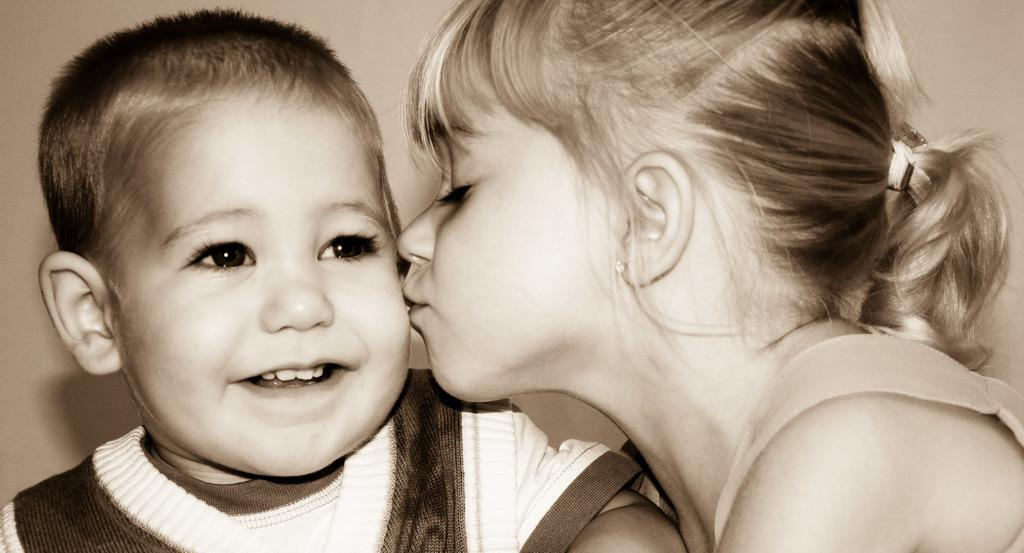Where was the image taken? The image is taken indoors. What can be seen in the background of the image? There is a wall in the background of the image. How many kids are in the image? There are two kids in the middle of the image. What is the girl doing to the boy in the image? The girl is kissing the boy on the cheeks. What type of animals can be seen at the zoo in the image? There is no zoo present in the image; it is taken indoors with two kids. What is the distance between the base and the sidewalk in the image? There is no base or sidewalk present in the image. 